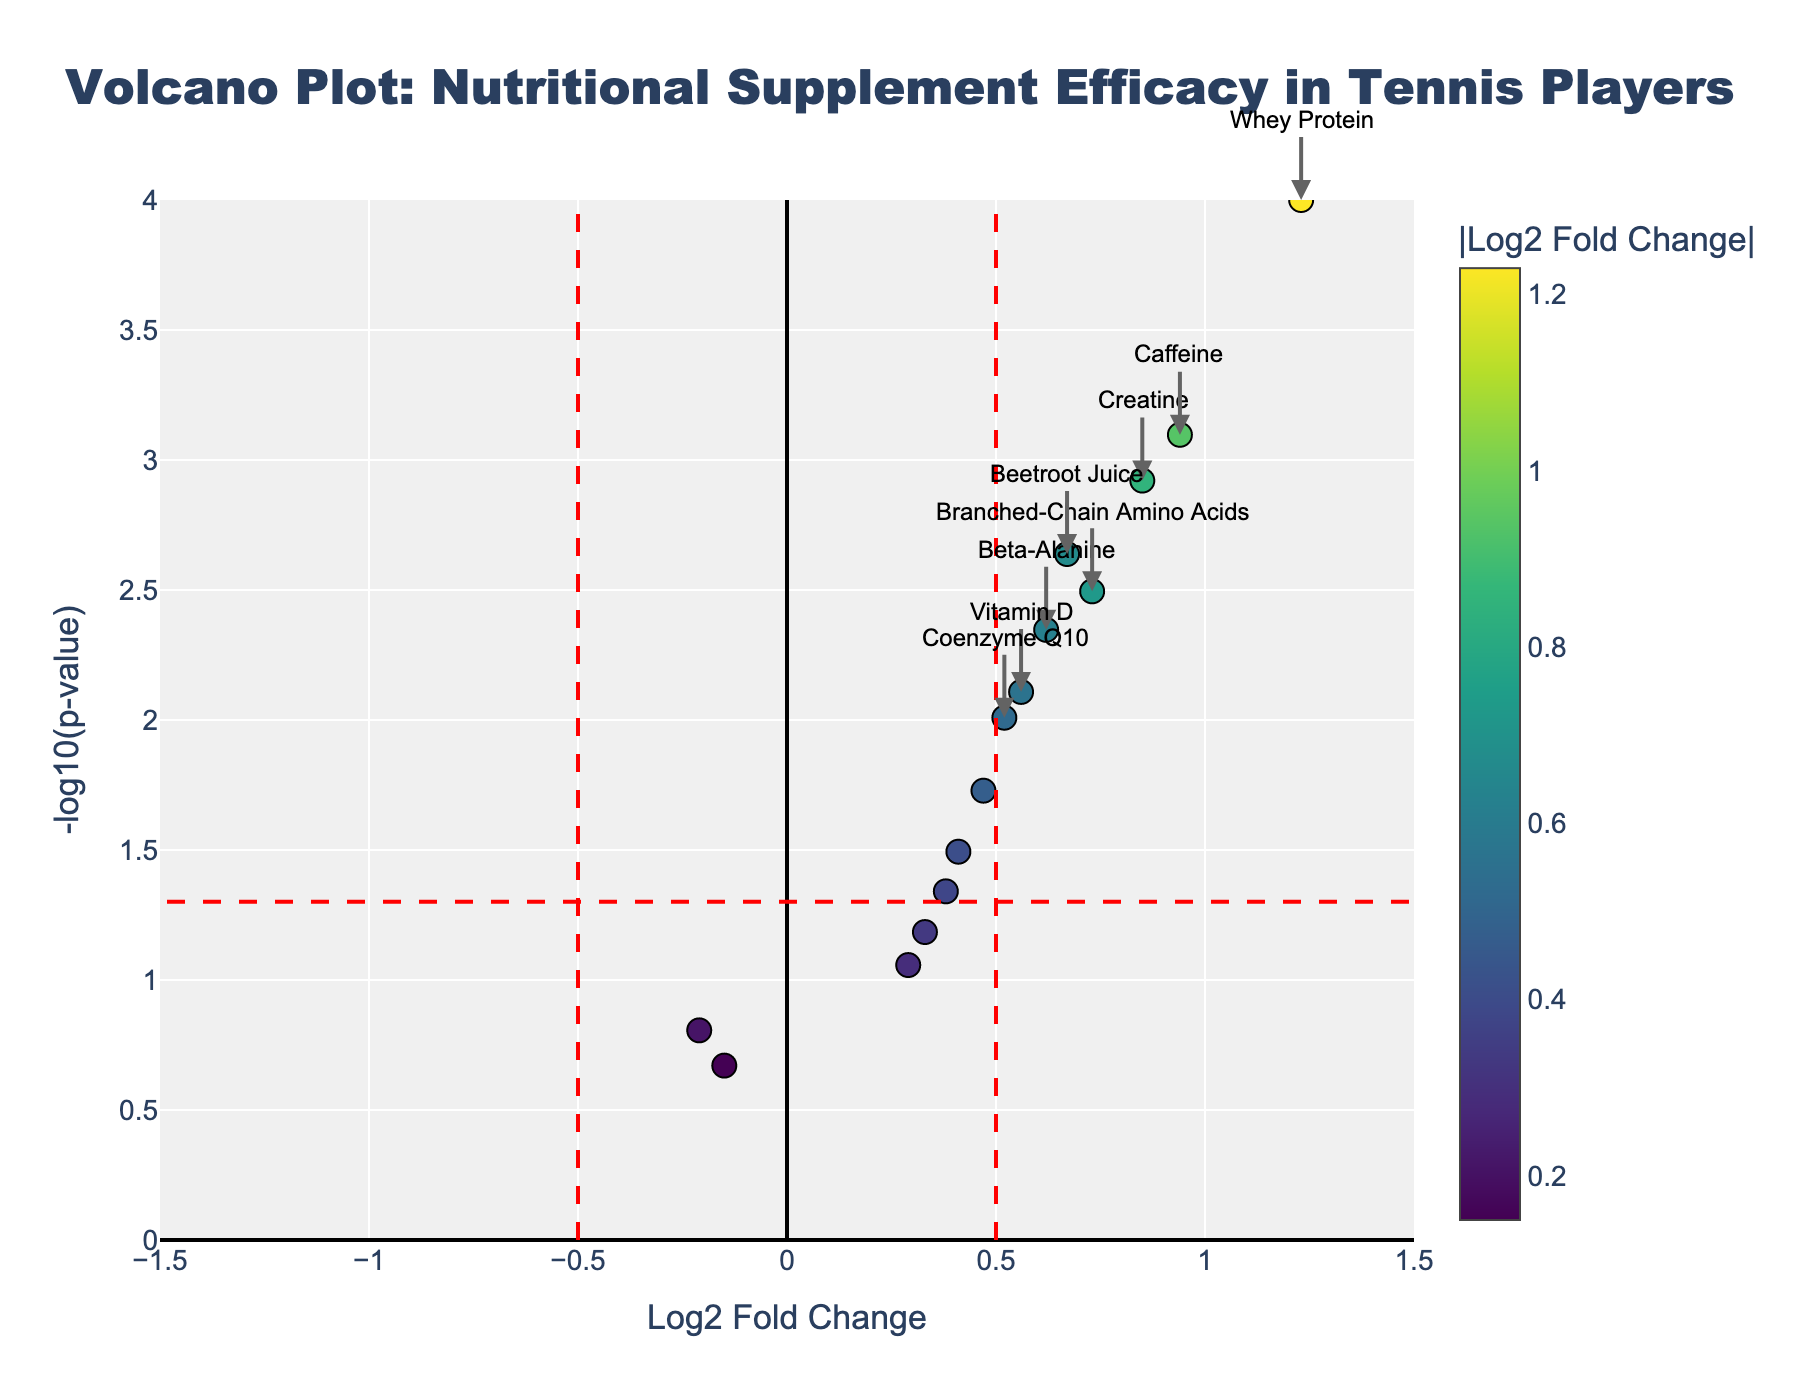What is the title of the plot? The title of the plot is usually displayed at the top. In this case, it says "Volcano Plot: Nutritional Supplement Efficacy in Tennis Players".
Answer: Volcano Plot: Nutritional Supplement Efficacy in Tennis Players What does the x-axis represent? The label for the x-axis is typically found below the horizontal axis. Here it indicates "Log2 Fold Change".
Answer: Log2 Fold Change Which supplement has the highest Log2 Fold Change? By looking at the x-axis with the largest value, Whey Protein is the farthest to the right, indicating it has the highest Log2 Fold Change.
Answer: Whey Protein How many supplements have a p-value less than 0.05? The horizontal red dashed line represents the p-value threshold of 0.05. All points above this line have a significant p-value. Counting these points gives us the number.
Answer: 9 Which supplement has the most statistically significant impact? The y-axis represents -log10(p-value). The higher the point, the more statistically significant the result. Whey Protein is the highest point on the plot.
Answer: Whey Protein Which supplement has the lowest Log2 Fold Change and is statistically significant? The statistically significant points are those above the horizontal line and to the sides of the vertical lines. The lowest Log2 Fold Change among these points is for Beta-Alanine.
Answer: Beta-Alanine What is the Log2 Fold Change for Beetroot Juice? By hovering or closely inspecting the point labeled "Beetroot Juice", the Log2 Fold Change value can be read.
Answer: 0.67 Is the supplement Omega-3 Fatty Acids considered statistically significant? Whether a supplement is significant can be determined if its point is above the horizontal red line. Omega-3 Fatty Acids is below this line.
Answer: No Compare the Log2 Fold Change of Vitamin D and Caffeine. Which one is higher? By locating the points for Vitamin D and Caffeine, the Log2 Fold Change for Vitamin D is 0.56 while for Caffeine it is 0.94.
Answer: Caffeine What is the Log2 Fold Change and p-value for Creatine? The specific point for Creatine shows the Log2 Fold Change is 0.85, and hovering over it reveals the p-value is 0.0012.
Answer: Log2 Fold Change: 0.85, p-value: 0.0012 